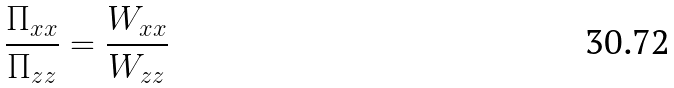<formula> <loc_0><loc_0><loc_500><loc_500>\frac { \Pi _ { x x } } { \Pi _ { z z } } = \frac { W _ { x x } } { W _ { z z } }</formula> 